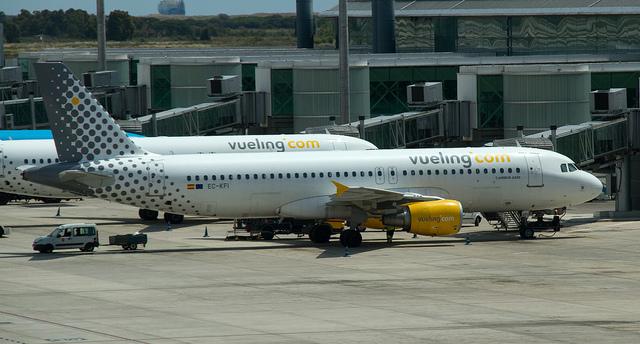What airline is it?
Answer briefly. Vueling. What is the plane for?
Be succinct. Flying. Is the airplane in the air?
Short answer required. No. 